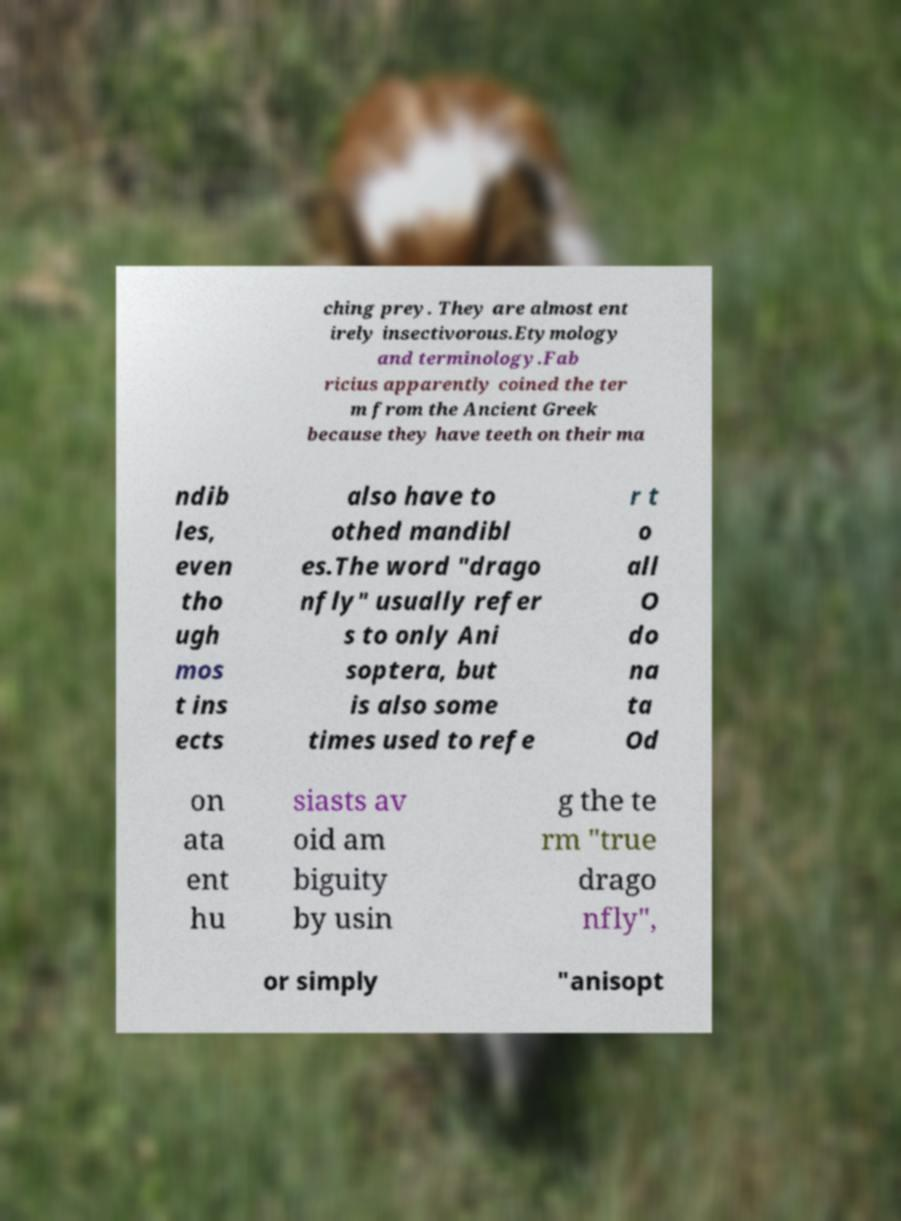Could you assist in decoding the text presented in this image and type it out clearly? ching prey. They are almost ent irely insectivorous.Etymology and terminology.Fab ricius apparently coined the ter m from the Ancient Greek because they have teeth on their ma ndib les, even tho ugh mos t ins ects also have to othed mandibl es.The word "drago nfly" usually refer s to only Ani soptera, but is also some times used to refe r t o all O do na ta Od on ata ent hu siasts av oid am biguity by usin g the te rm "true drago nfly", or simply "anisopt 